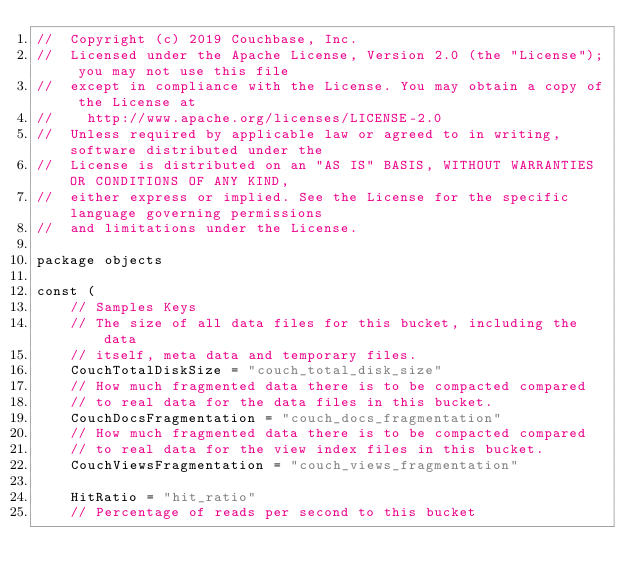<code> <loc_0><loc_0><loc_500><loc_500><_Go_>//  Copyright (c) 2019 Couchbase, Inc.
//  Licensed under the Apache License, Version 2.0 (the "License"); you may not use this file
//  except in compliance with the License. You may obtain a copy of the License at
//    http://www.apache.org/licenses/LICENSE-2.0
//  Unless required by applicable law or agreed to in writing, software distributed under the
//  License is distributed on an "AS IS" BASIS, WITHOUT WARRANTIES OR CONDITIONS OF ANY KIND,
//  either express or implied. See the License for the specific language governing permissions
//  and limitations under the License.

package objects

const (
	// Samples Keys
	// The size of all data files for this bucket, including the data
	// itself, meta data and temporary files.
	CouchTotalDiskSize = "couch_total_disk_size"
	// How much fragmented data there is to be compacted compared
	// to real data for the data files in this bucket.
	CouchDocsFragmentation = "couch_docs_fragmentation"
	// How much fragmented data there is to be compacted compared
	// to real data for the view index files in this bucket.
	CouchViewsFragmentation = "couch_views_fragmentation"

	HitRatio = "hit_ratio"
	// Percentage of reads per second to this bucket</code> 